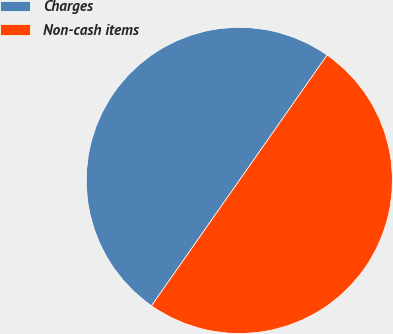Convert chart to OTSL. <chart><loc_0><loc_0><loc_500><loc_500><pie_chart><fcel>Charges<fcel>Non-cash items<nl><fcel>50.0%<fcel>50.0%<nl></chart> 